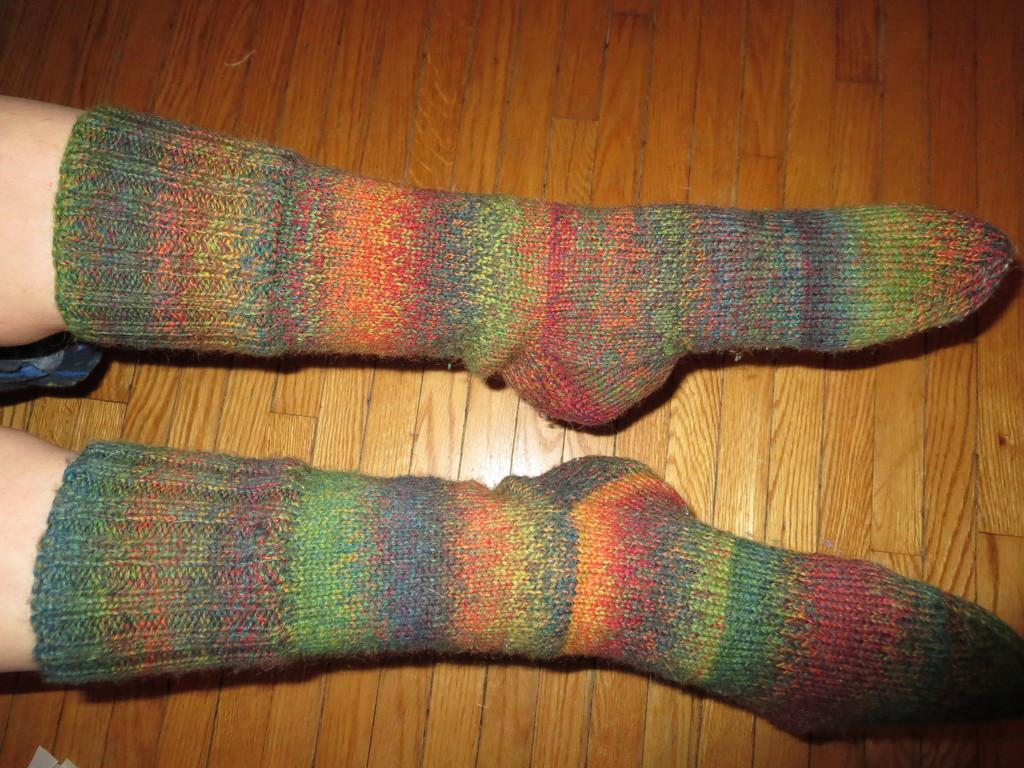What part of the boy's body is visible in the image? There is a boy's leg in the image. What type of clothing is on the boy's leg? The boy's leg has colorful socks. What type of flooring is visible in the image? The wooden flooring is visible in the image. What type of blade is being used by the boy in the image? There is no blade present in the image; it only shows a boy's leg with colorful socks. What type of cap is the boy wearing in the image? There is no cap visible in the image; only the boy's leg and socks are present. 